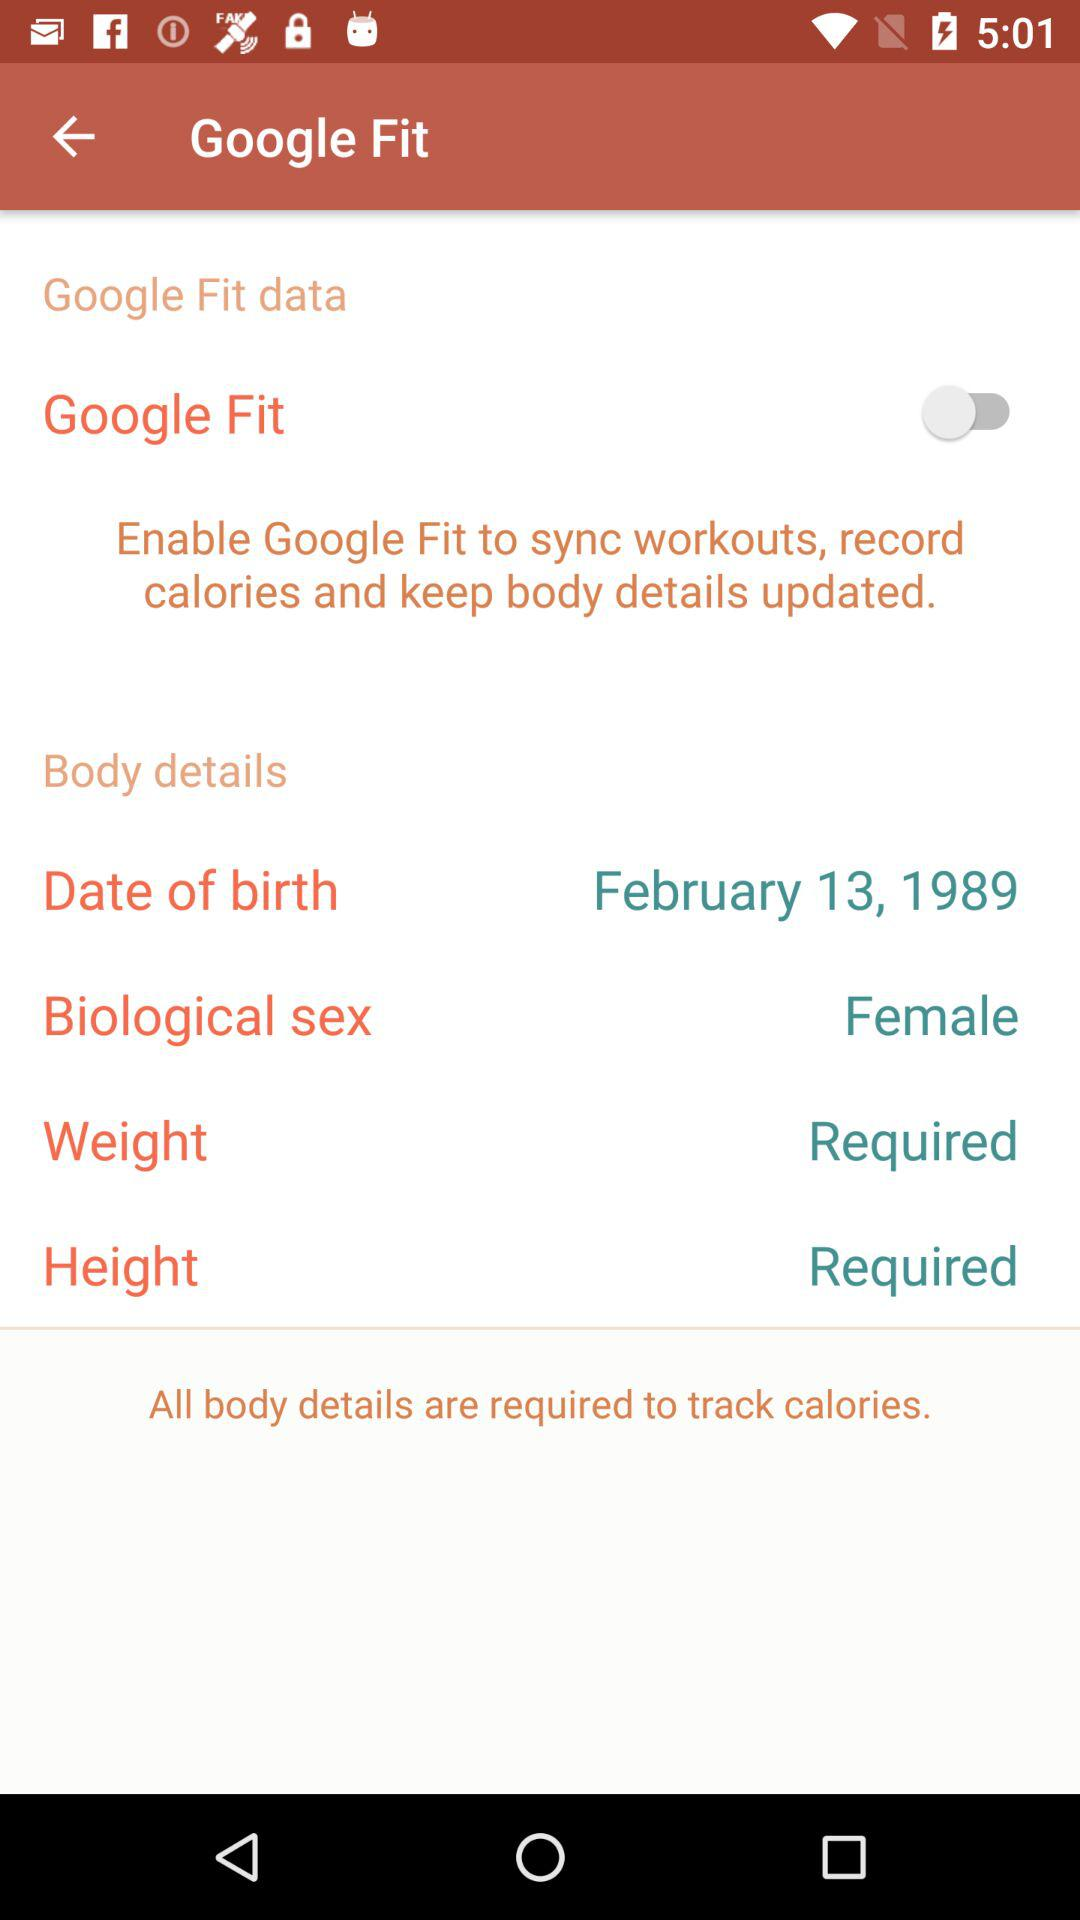What is "Biological sex"? The biological sex is "Female". 